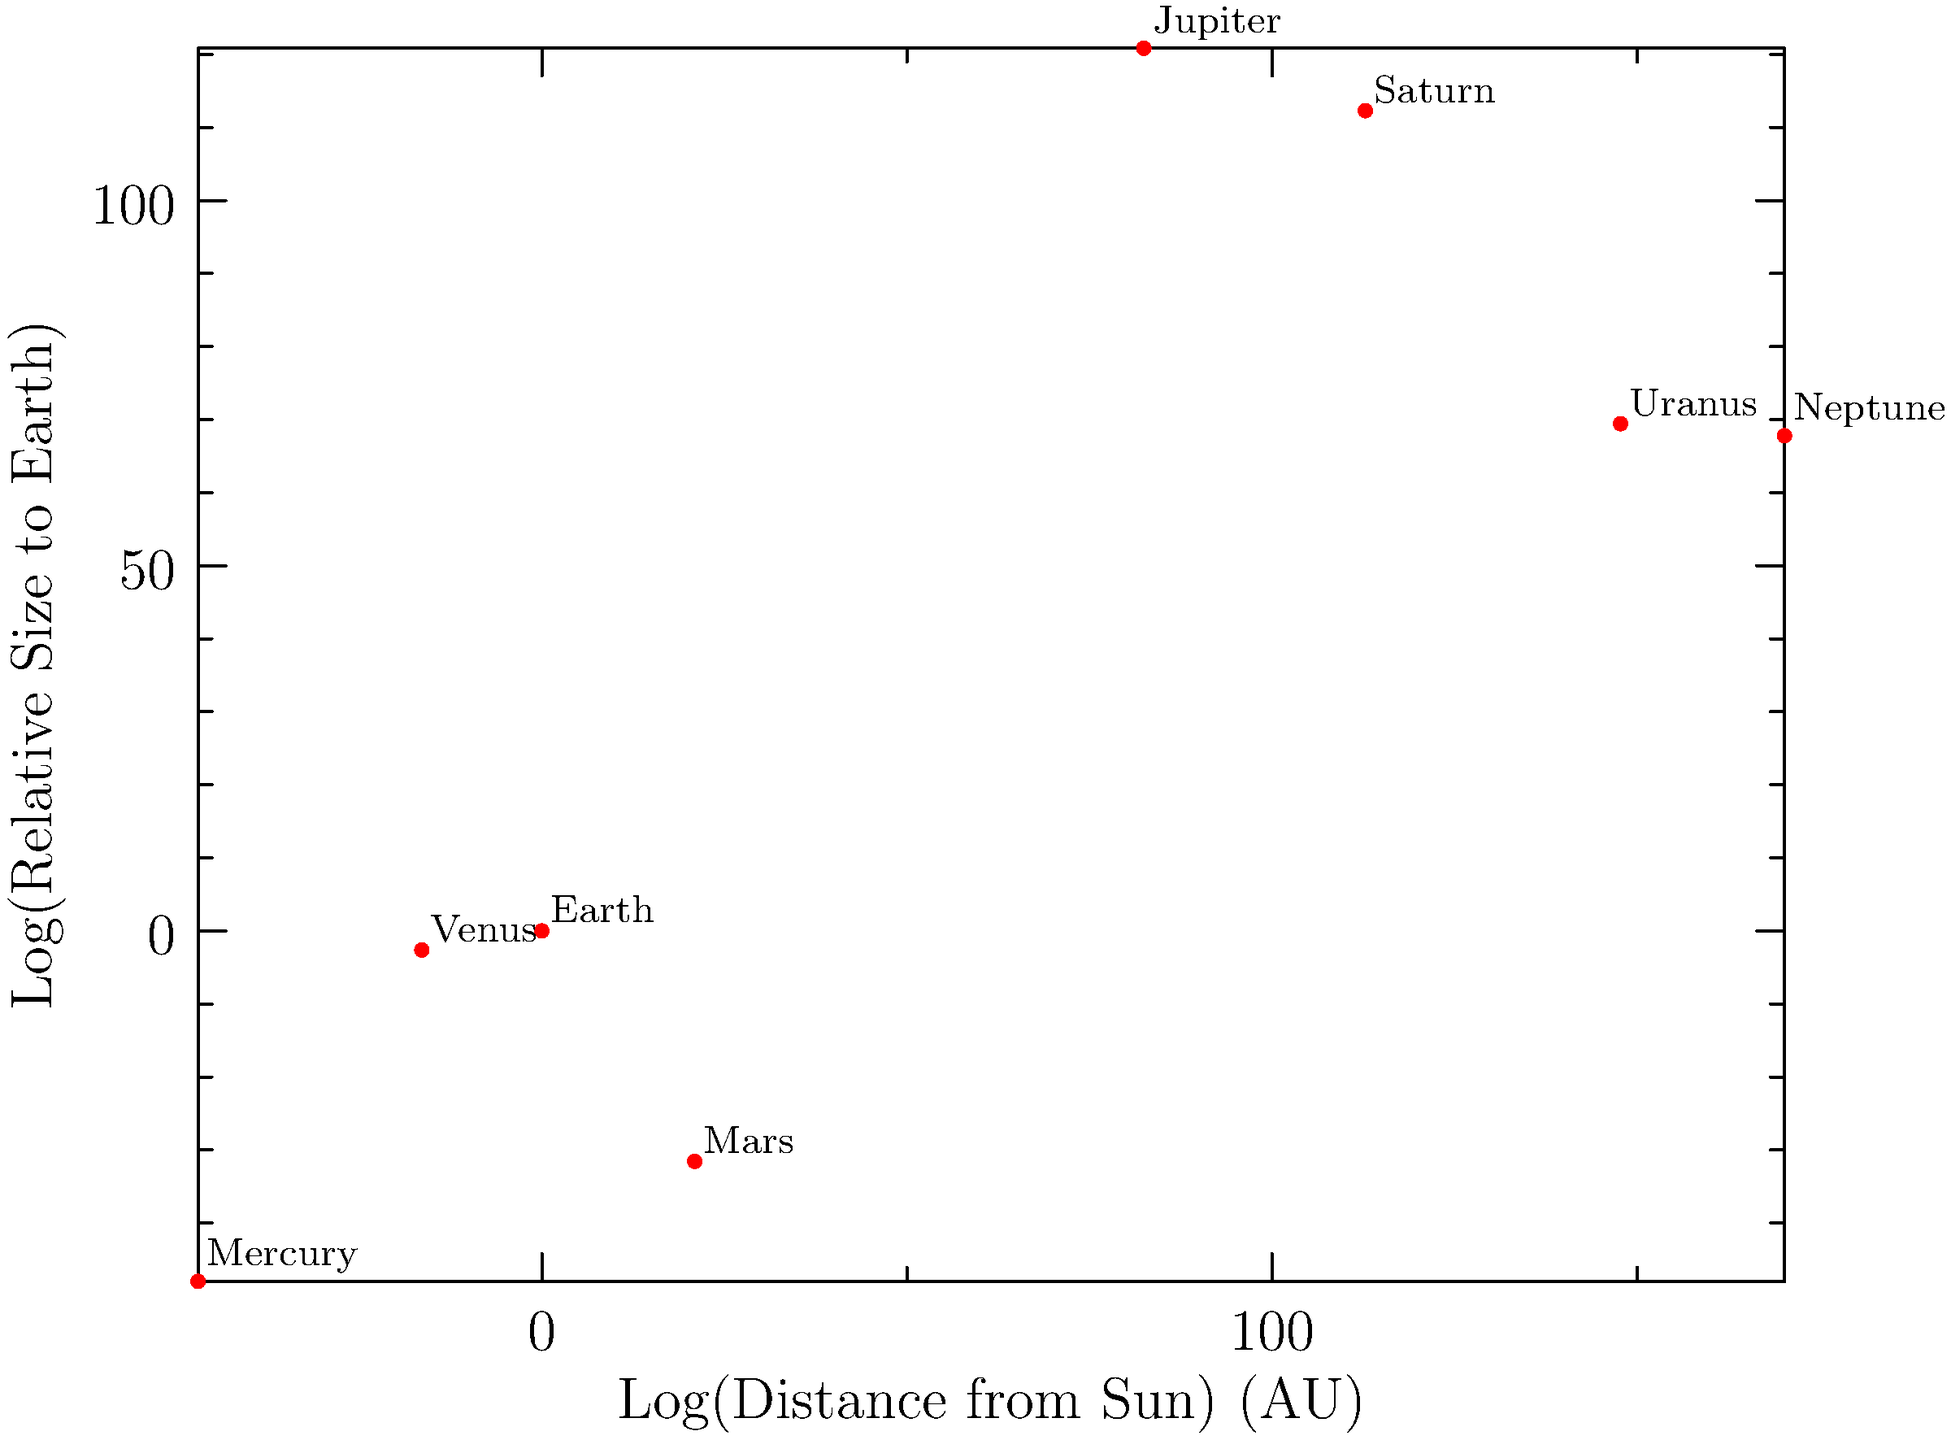Given the logarithmic plot of planet sizes versus their distances from the Sun, which economic principle might explain the observed distribution of planets in our solar system, and how could this understanding be applied to regulatory policies in space exploration and resource allocation? To answer this question, let's break it down step-by-step:

1. Observe the plot: The graph shows a logarithmic representation of planet sizes relative to Earth versus their distances from the Sun in Astronomical Units (AU).

2. Identify the pattern: There's a general trend of larger planets being farther from the Sun, with some exceptions (e.g., Mars).

3. Economic principle: This distribution resembles the concept of "economies of scale" in economics. In this context:
   a) Larger planets (Jupiter, Saturn, Uranus, Neptune) have formed farther from the Sun where more material was available.
   b) Smaller, rocky planets formed closer to the Sun where less material was available.

4. Economic interpretation: The "market" of planet formation allocated resources (space and materials) efficiently based on gravitational forces and available matter.

5. Application to regulatory policies:
   a) Resource allocation: Regulators could use this principle to guide policies on space mining and resource extraction, focusing on different types of resources for different planetary bodies.
   b) Risk assessment: Understanding the distribution of planetary sizes and compositions can inform policies on space exploration safety and investment.
   c) Long-term planning: This knowledge can guide policies for sustainable space exploration and potential colonization efforts.

6. Policy implications:
   a) Encourage research and development in technologies suitable for different planetary environments.
   b) Develop guidelines for responsible resource extraction in space.
   c) Create incentives for private sector involvement in space exploration that aligns with the natural resource distribution.

7. Economic impact: These policies could stimulate economic growth in the space sector while ensuring sustainable and responsible exploration and utilization of space resources.
Answer: Economies of scale principle applied to space resource allocation and exploration policies. 